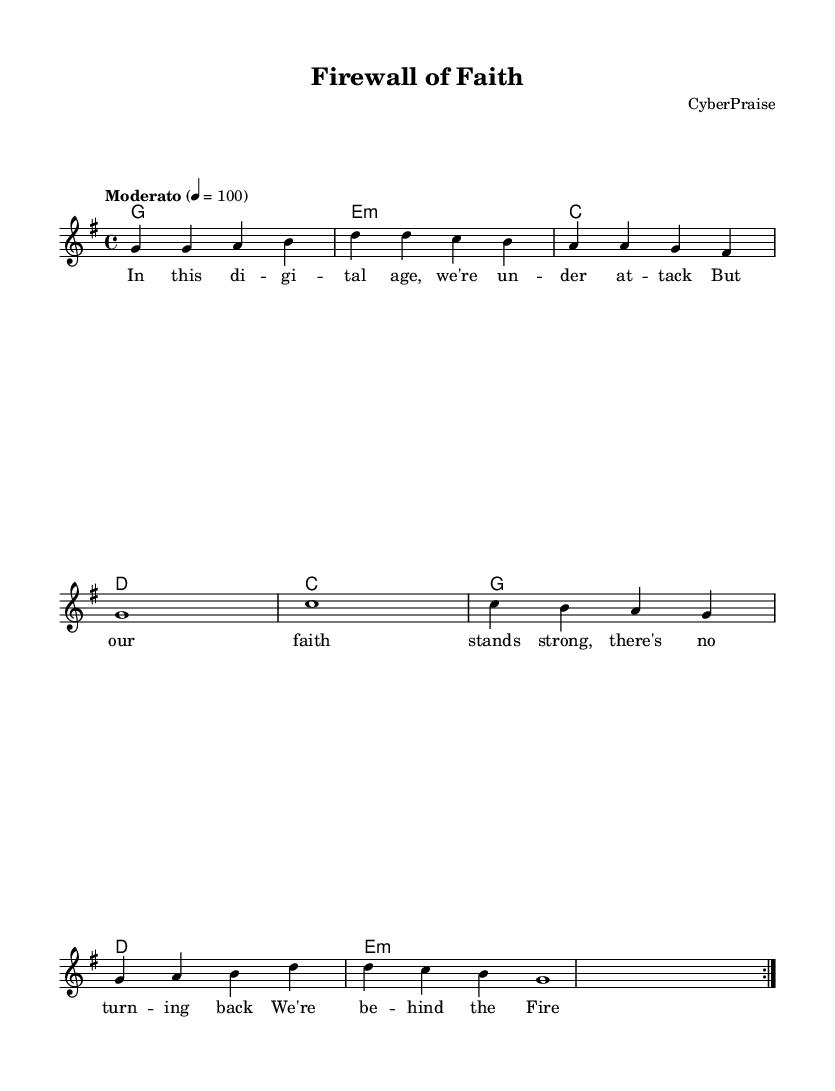What is the key signature of this music? The key signature is indicated at the beginning of the score. It shows one sharp (F#), which corresponds to G major.
Answer: G major What is the time signature of this music? The time signature is shown at the beginning of the score, indicating how many beats there are in a measure and what type of note gets the beat. It shows 4/4, meaning there are four beats per measure and a quarter note receives one beat.
Answer: 4/4 How many measures are in the repeated section? The repeated section consists of two sets of measures, with each set containing four measures. Since it's repeated, we consider both sets, totaling eight unique measures.
Answer: Eight What is the tempo of the piece? The tempo is defined above the melody section with the marking "Moderato" and a metronome marking of 100 beats per minute. This indicates a moderate speed for the piece.
Answer: Moderato 100 What themes are explored in the lyrics? The lyrics reflect themes of faith, digital vulnerability, and the protection that faith provides from external threats. This connects the concepts of cybersecurity and spirituality.
Answer: Faith and digital security What chord comes after the first measure of the verse? The first measure of the verse corresponds to the first chord indicated in the chord progression, which is G major, as shown in the chord mode section.
Answer: G major 